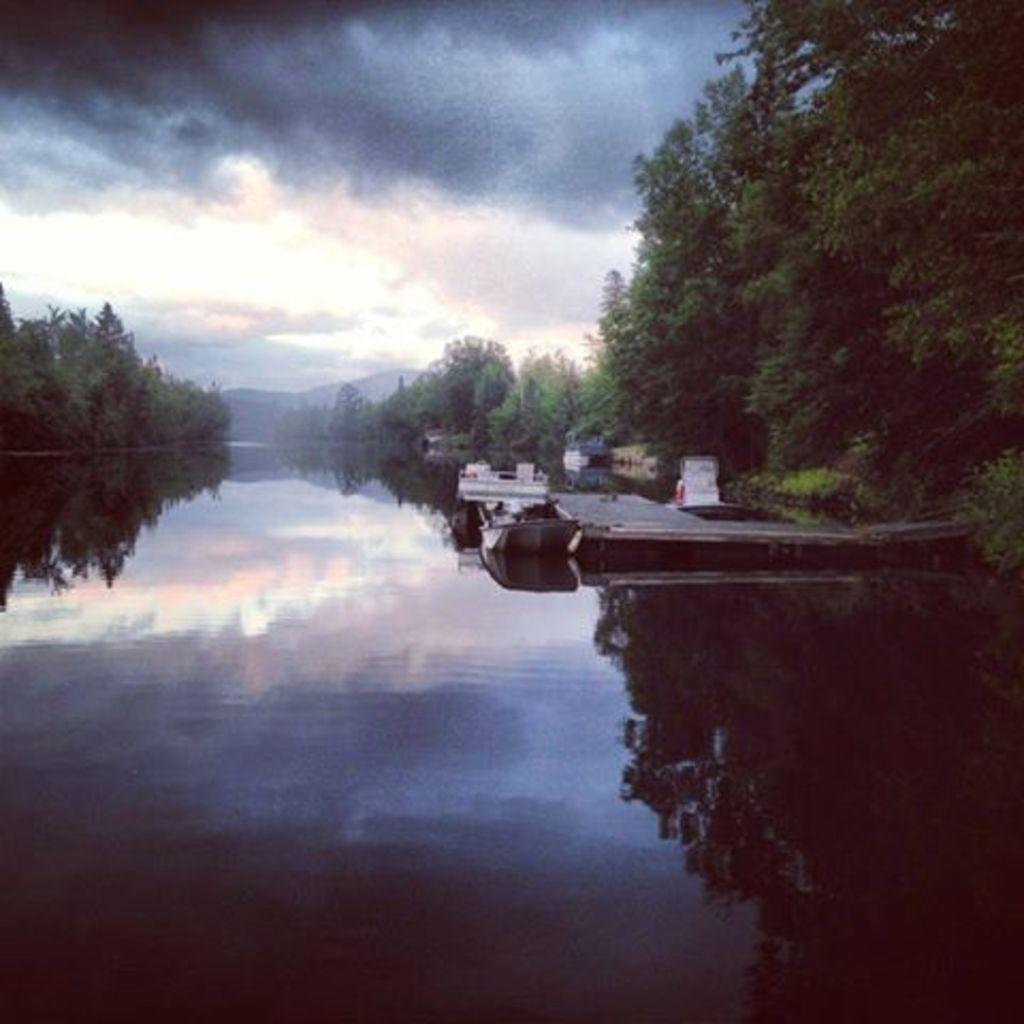What is the main feature of the image? The main feature of the image is water. What is located beside the water? There is a boat beside the water. What type of vegetation is present on either side of the water? Trees are present on either side of the water. What is visible at the top of the image? The sky is visible at the top of the image. How many weeks does the cemetery appear in the image? There is no cemetery present in the image. What type of tail is attached to the boat in the image? There is no tail attached to the boat in the image. 